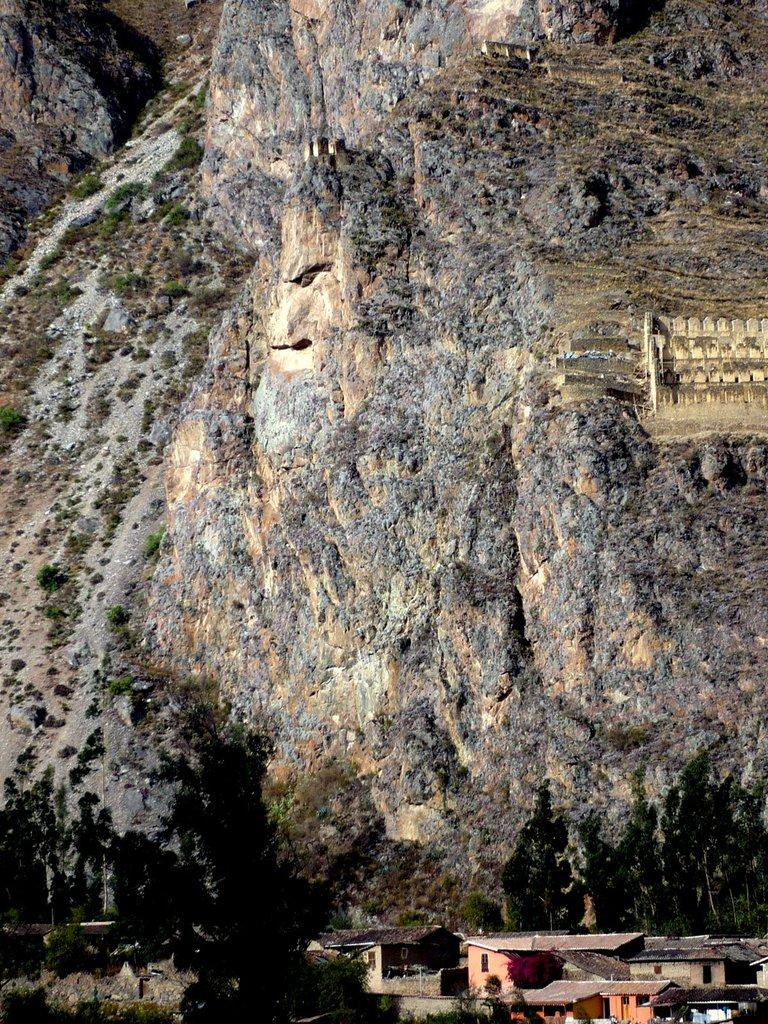What type of structure is visible in the image? There is a building in the image. What can be seen on the hills in the image? There is a group of trees on the hills in the image. Are there any other buildings visible in the image? Yes, there are buildings on the bottom of the image. What else can be found on the bottom of the image besides buildings? There is a group of trees on the bottom of the image. What type of brain is visible in the image? There is no brain present in the image. What rules are being followed by the trees in the image? Trees do not follow rules, so this question cannot be answered. 